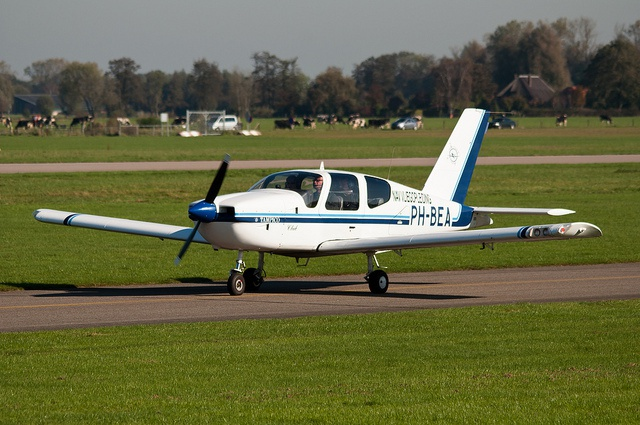Describe the objects in this image and their specific colors. I can see airplane in gray, white, black, and darkgreen tones, car in gray, lightgray, darkgray, and teal tones, car in gray, black, darkblue, and darkgreen tones, car in gray, black, darkgray, and lightgray tones, and people in gray, black, blue, and brown tones in this image. 